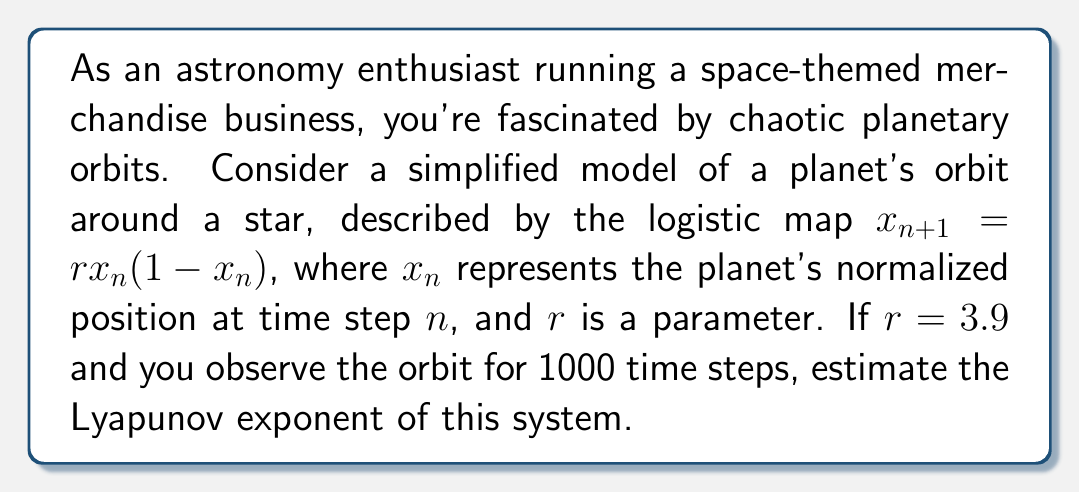Can you solve this math problem? To estimate the Lyapunov exponent for this chaotic planetary orbit, we'll follow these steps:

1) The Lyapunov exponent ($\lambda$) for a 1D map is given by:

   $$\lambda = \lim_{N \to \infty} \frac{1}{N} \sum_{n=0}^{N-1} \ln |f'(x_n)|$$

   where $f'(x_n)$ is the derivative of the map at $x_n$.

2) For the logistic map $f(x) = rx(1-x)$, the derivative is:

   $$f'(x) = r(1-2x)$$

3) We need to iterate the map and calculate $\ln |f'(x_n)|$ for each step:

   Initialize: $x_0 = 0.5$ (arbitrary starting point)
   For $n = 0$ to 999:
     $x_{n+1} = 3.9 x_n(1-x_n)$
     Calculate: $\ln |3.9(1-2x_n)|$

4) Sum all these logarithms and divide by N (1000 in this case).

5) In practice, we would use a computer to perform these calculations. The result after 1000 iterations would approximate the Lyapunov exponent.

6) For $r = 3.9$, the theoretical Lyapunov exponent is approximately 0.6946, which indicates chaotic behavior (positive Lyapunov exponent).

Note: The actual numerical result may slightly deviate from the theoretical value due to finite sampling and initial condition sensitivity.
Answer: $\lambda \approx 0.6946$ 